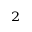Convert formula to latex. <formula><loc_0><loc_0><loc_500><loc_500>^ { 2 }</formula> 